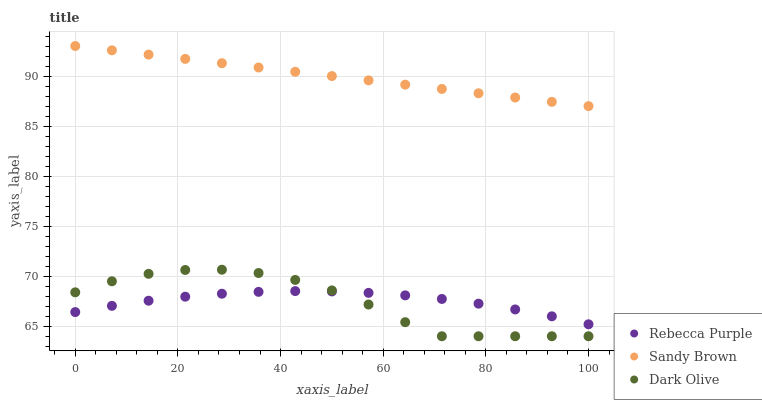Does Dark Olive have the minimum area under the curve?
Answer yes or no. Yes. Does Sandy Brown have the maximum area under the curve?
Answer yes or no. Yes. Does Rebecca Purple have the minimum area under the curve?
Answer yes or no. No. Does Rebecca Purple have the maximum area under the curve?
Answer yes or no. No. Is Sandy Brown the smoothest?
Answer yes or no. Yes. Is Dark Olive the roughest?
Answer yes or no. Yes. Is Rebecca Purple the smoothest?
Answer yes or no. No. Is Rebecca Purple the roughest?
Answer yes or no. No. Does Dark Olive have the lowest value?
Answer yes or no. Yes. Does Rebecca Purple have the lowest value?
Answer yes or no. No. Does Sandy Brown have the highest value?
Answer yes or no. Yes. Does Rebecca Purple have the highest value?
Answer yes or no. No. Is Rebecca Purple less than Sandy Brown?
Answer yes or no. Yes. Is Sandy Brown greater than Rebecca Purple?
Answer yes or no. Yes. Does Rebecca Purple intersect Dark Olive?
Answer yes or no. Yes. Is Rebecca Purple less than Dark Olive?
Answer yes or no. No. Is Rebecca Purple greater than Dark Olive?
Answer yes or no. No. Does Rebecca Purple intersect Sandy Brown?
Answer yes or no. No. 